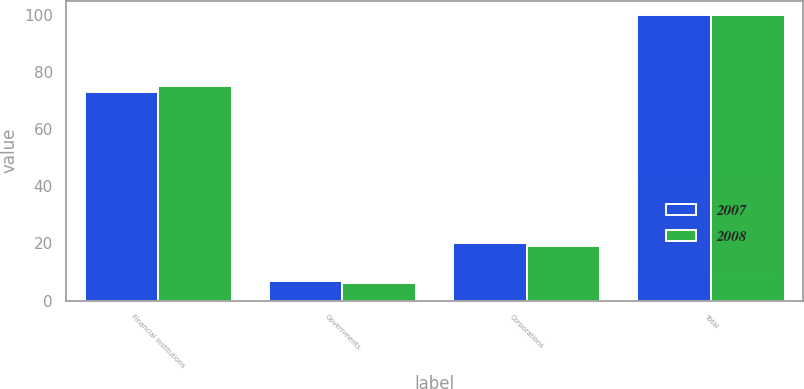Convert chart. <chart><loc_0><loc_0><loc_500><loc_500><stacked_bar_chart><ecel><fcel>Financial institutions<fcel>Governments<fcel>Corporations<fcel>Total<nl><fcel>2007<fcel>73<fcel>7<fcel>20<fcel>100<nl><fcel>2008<fcel>75<fcel>6<fcel>19<fcel>100<nl></chart> 